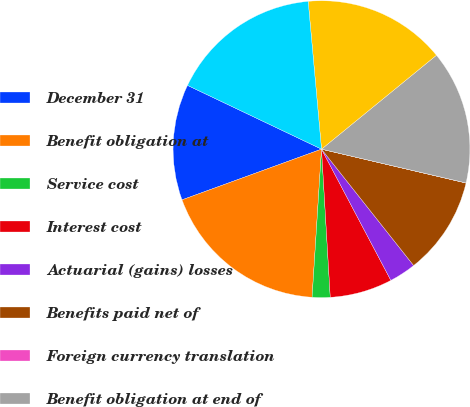<chart> <loc_0><loc_0><loc_500><loc_500><pie_chart><fcel>December 31<fcel>Benefit obligation at<fcel>Service cost<fcel>Interest cost<fcel>Actuarial (gains) losses<fcel>Benefits paid net of<fcel>Foreign currency translation<fcel>Benefit obligation at end of<fcel>Funded status<fcel>Net funded status<nl><fcel>12.62%<fcel>18.44%<fcel>1.95%<fcel>6.8%<fcel>2.92%<fcel>10.68%<fcel>0.01%<fcel>14.56%<fcel>15.53%<fcel>16.5%<nl></chart> 